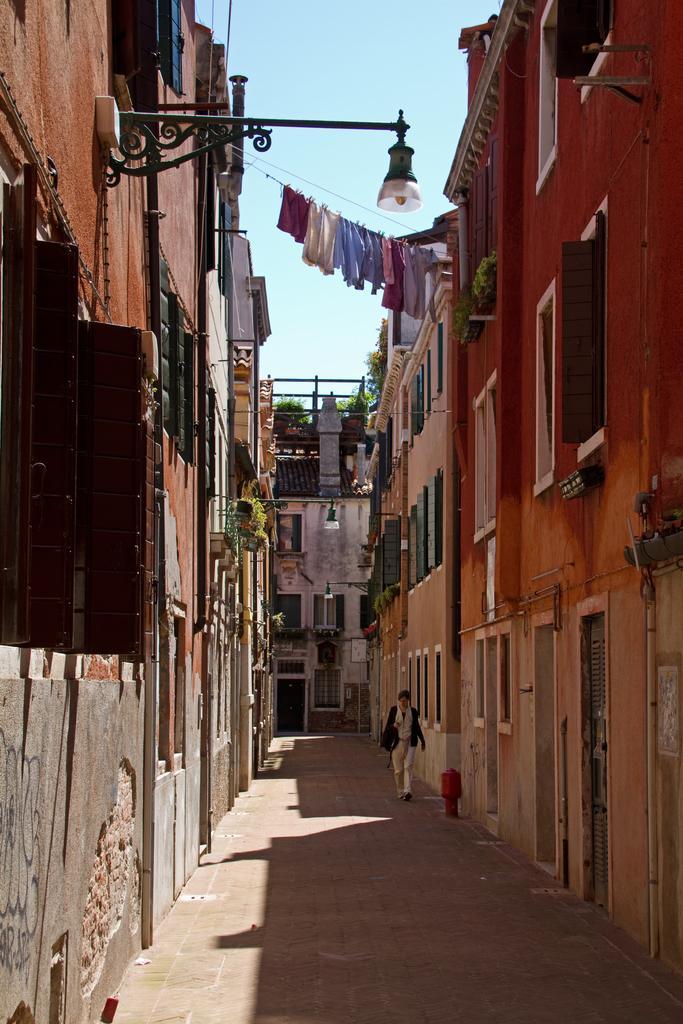Please provide a concise description of this image. In this image, in the middle there are buildings, women, clothes, lights, windows, plants, floor, sky. 